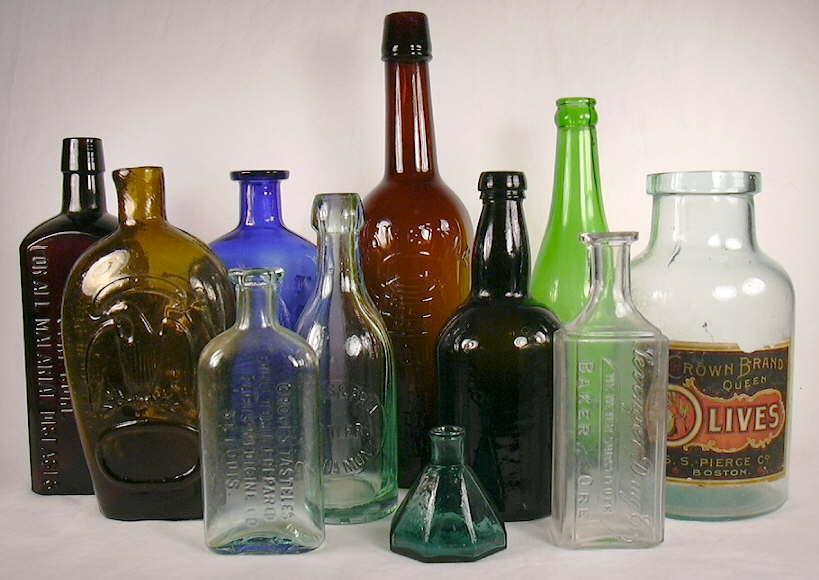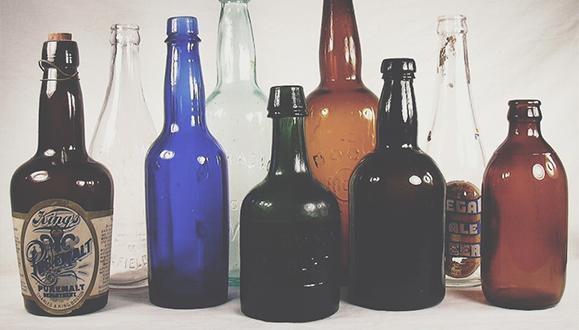The first image is the image on the left, the second image is the image on the right. Given the left and right images, does the statement "The left image contains three or more different bottles while the right image contains only a single bottle." hold true? Answer yes or no. No. The first image is the image on the left, the second image is the image on the right. Analyze the images presented: Is the assertion "Two cobalt blue bottles are sitting among at least 18 other colorful bottles." valid? Answer yes or no. Yes. 